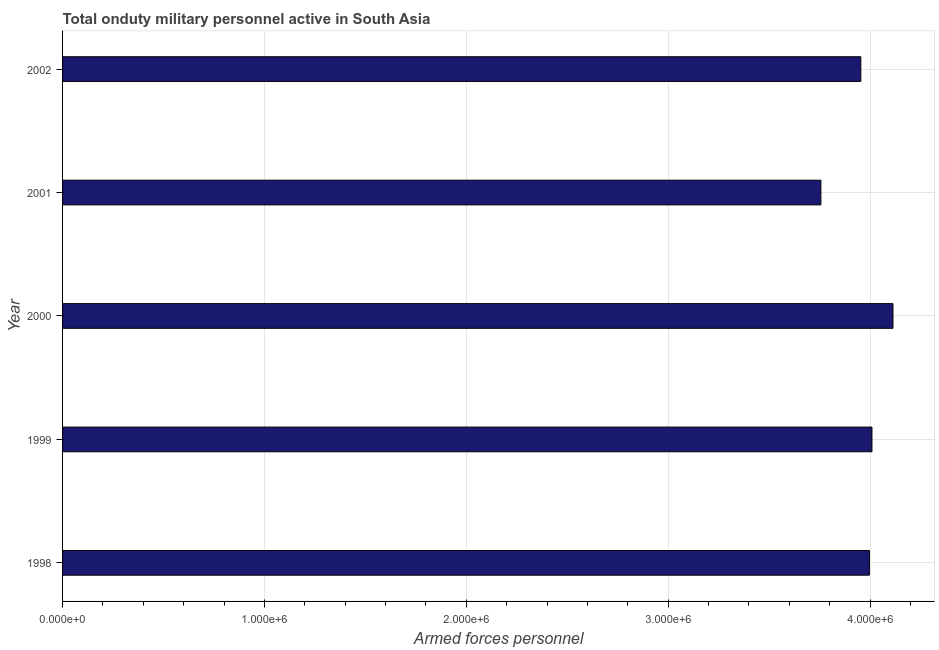What is the title of the graph?
Provide a succinct answer. Total onduty military personnel active in South Asia. What is the label or title of the X-axis?
Offer a very short reply. Armed forces personnel. What is the label or title of the Y-axis?
Your answer should be compact. Year. What is the number of armed forces personnel in 2001?
Your answer should be very brief. 3.76e+06. Across all years, what is the maximum number of armed forces personnel?
Keep it short and to the point. 4.11e+06. Across all years, what is the minimum number of armed forces personnel?
Your answer should be very brief. 3.76e+06. In which year was the number of armed forces personnel maximum?
Your response must be concise. 2000. In which year was the number of armed forces personnel minimum?
Provide a succinct answer. 2001. What is the sum of the number of armed forces personnel?
Offer a very short reply. 1.98e+07. What is the difference between the number of armed forces personnel in 1999 and 2001?
Provide a short and direct response. 2.53e+05. What is the average number of armed forces personnel per year?
Keep it short and to the point. 3.97e+06. What is the median number of armed forces personnel?
Provide a short and direct response. 4.00e+06. Do a majority of the years between 2002 and 1999 (inclusive) have number of armed forces personnel greater than 2000000 ?
Offer a very short reply. Yes. Is the number of armed forces personnel in 1998 less than that in 1999?
Your response must be concise. Yes. Is the difference between the number of armed forces personnel in 1998 and 2002 greater than the difference between any two years?
Ensure brevity in your answer.  No. What is the difference between the highest and the second highest number of armed forces personnel?
Offer a very short reply. 1.04e+05. Is the sum of the number of armed forces personnel in 1999 and 2000 greater than the maximum number of armed forces personnel across all years?
Your answer should be very brief. Yes. What is the difference between the highest and the lowest number of armed forces personnel?
Offer a very short reply. 3.57e+05. How many bars are there?
Your answer should be compact. 5. Are all the bars in the graph horizontal?
Ensure brevity in your answer.  Yes. How many years are there in the graph?
Your answer should be compact. 5. What is the difference between two consecutive major ticks on the X-axis?
Ensure brevity in your answer.  1.00e+06. Are the values on the major ticks of X-axis written in scientific E-notation?
Make the answer very short. Yes. What is the Armed forces personnel in 1998?
Provide a short and direct response. 4.00e+06. What is the Armed forces personnel in 1999?
Offer a very short reply. 4.01e+06. What is the Armed forces personnel in 2000?
Your answer should be very brief. 4.11e+06. What is the Armed forces personnel of 2001?
Your answer should be very brief. 3.76e+06. What is the Armed forces personnel of 2002?
Keep it short and to the point. 3.95e+06. What is the difference between the Armed forces personnel in 1998 and 1999?
Provide a succinct answer. -1.26e+04. What is the difference between the Armed forces personnel in 1998 and 2000?
Keep it short and to the point. -1.17e+05. What is the difference between the Armed forces personnel in 1998 and 2001?
Keep it short and to the point. 2.40e+05. What is the difference between the Armed forces personnel in 1998 and 2002?
Your response must be concise. 4.25e+04. What is the difference between the Armed forces personnel in 1999 and 2000?
Your answer should be compact. -1.04e+05. What is the difference between the Armed forces personnel in 1999 and 2001?
Make the answer very short. 2.53e+05. What is the difference between the Armed forces personnel in 1999 and 2002?
Provide a short and direct response. 5.51e+04. What is the difference between the Armed forces personnel in 2000 and 2001?
Offer a very short reply. 3.57e+05. What is the difference between the Armed forces personnel in 2000 and 2002?
Give a very brief answer. 1.59e+05. What is the difference between the Armed forces personnel in 2001 and 2002?
Your response must be concise. -1.98e+05. What is the ratio of the Armed forces personnel in 1998 to that in 1999?
Your response must be concise. 1. What is the ratio of the Armed forces personnel in 1998 to that in 2001?
Offer a very short reply. 1.06. What is the ratio of the Armed forces personnel in 1999 to that in 2000?
Your answer should be very brief. 0.97. What is the ratio of the Armed forces personnel in 1999 to that in 2001?
Your response must be concise. 1.07. What is the ratio of the Armed forces personnel in 1999 to that in 2002?
Provide a short and direct response. 1.01. What is the ratio of the Armed forces personnel in 2000 to that in 2001?
Ensure brevity in your answer.  1.09. 